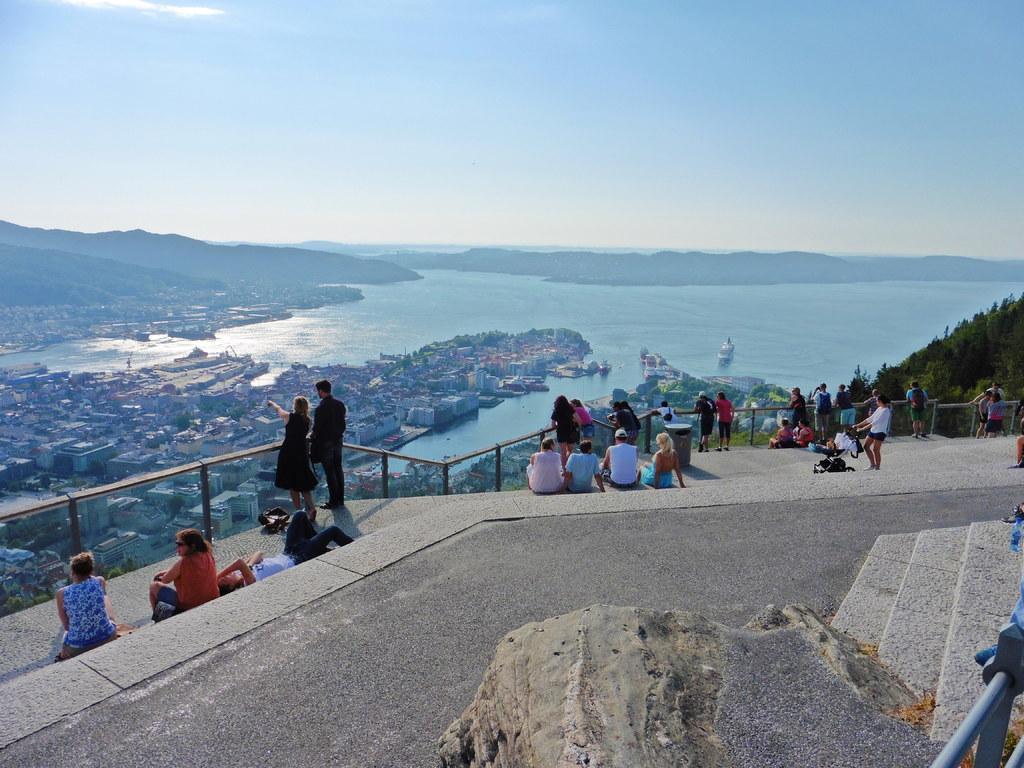How would you summarize this image in a sentence or two? In this picture I can observe some people sitting on the floor. Some of them are standing near the railing. There are men and women in this picture. In the background I can observe buildings, river and sky. 